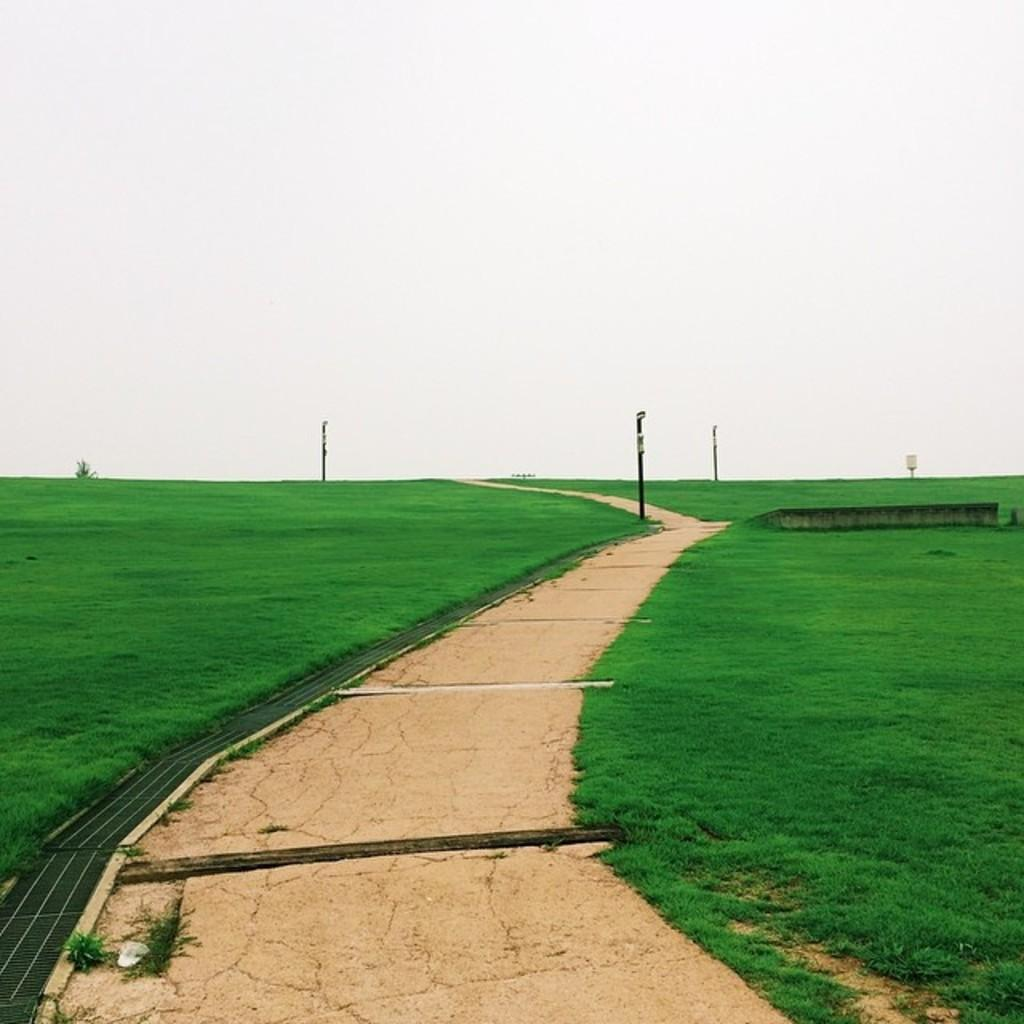What type of vegetation is present on the ground in the image? There is green grass on the ground in the image. What other types of vegetation can be seen in the image? There are bushes in the image. What structures are present in the image? There are poles and a road in the image. What objects are on the ground in the image? There are objects on the ground in the image. What is visible at the top of the image? The sky is visible at the top of the image. What type of instrument is being played by the sisters in the image? There are no sisters or instruments present in the image. What amusement park can be seen in the background of the image? There is no amusement park visible in the image; it features green grass, bushes, poles, a road, and objects on the ground. 